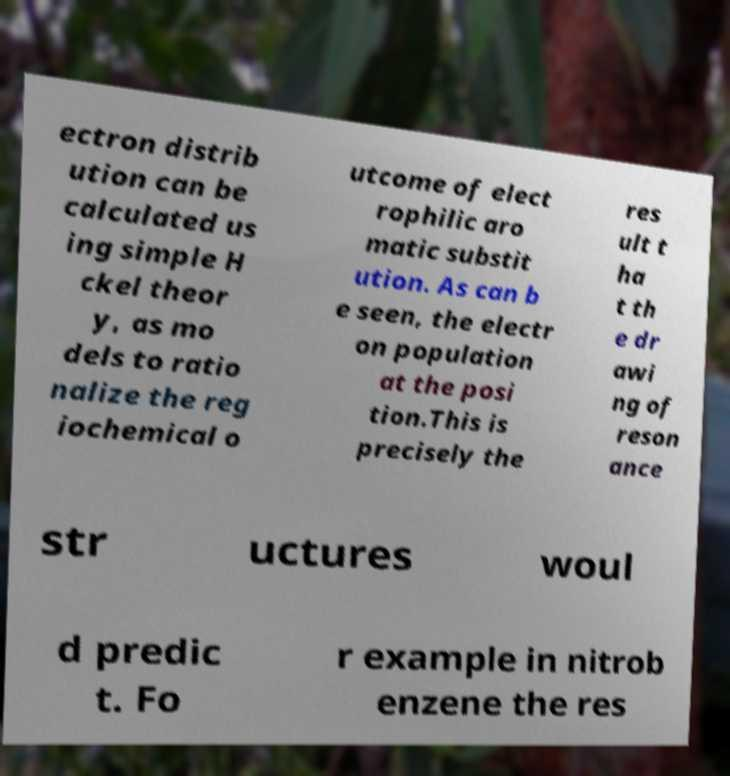Can you accurately transcribe the text from the provided image for me? ectron distrib ution can be calculated us ing simple H ckel theor y, as mo dels to ratio nalize the reg iochemical o utcome of elect rophilic aro matic substit ution. As can b e seen, the electr on population at the posi tion.This is precisely the res ult t ha t th e dr awi ng of reson ance str uctures woul d predic t. Fo r example in nitrob enzene the res 